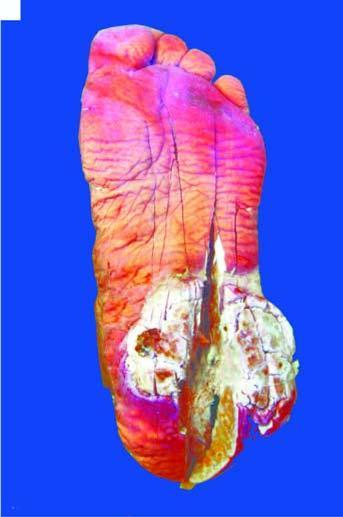what shows a fungating and ulcerated growth?
Answer the question using a single word or phrase. Skin surface on the sole of the foot 